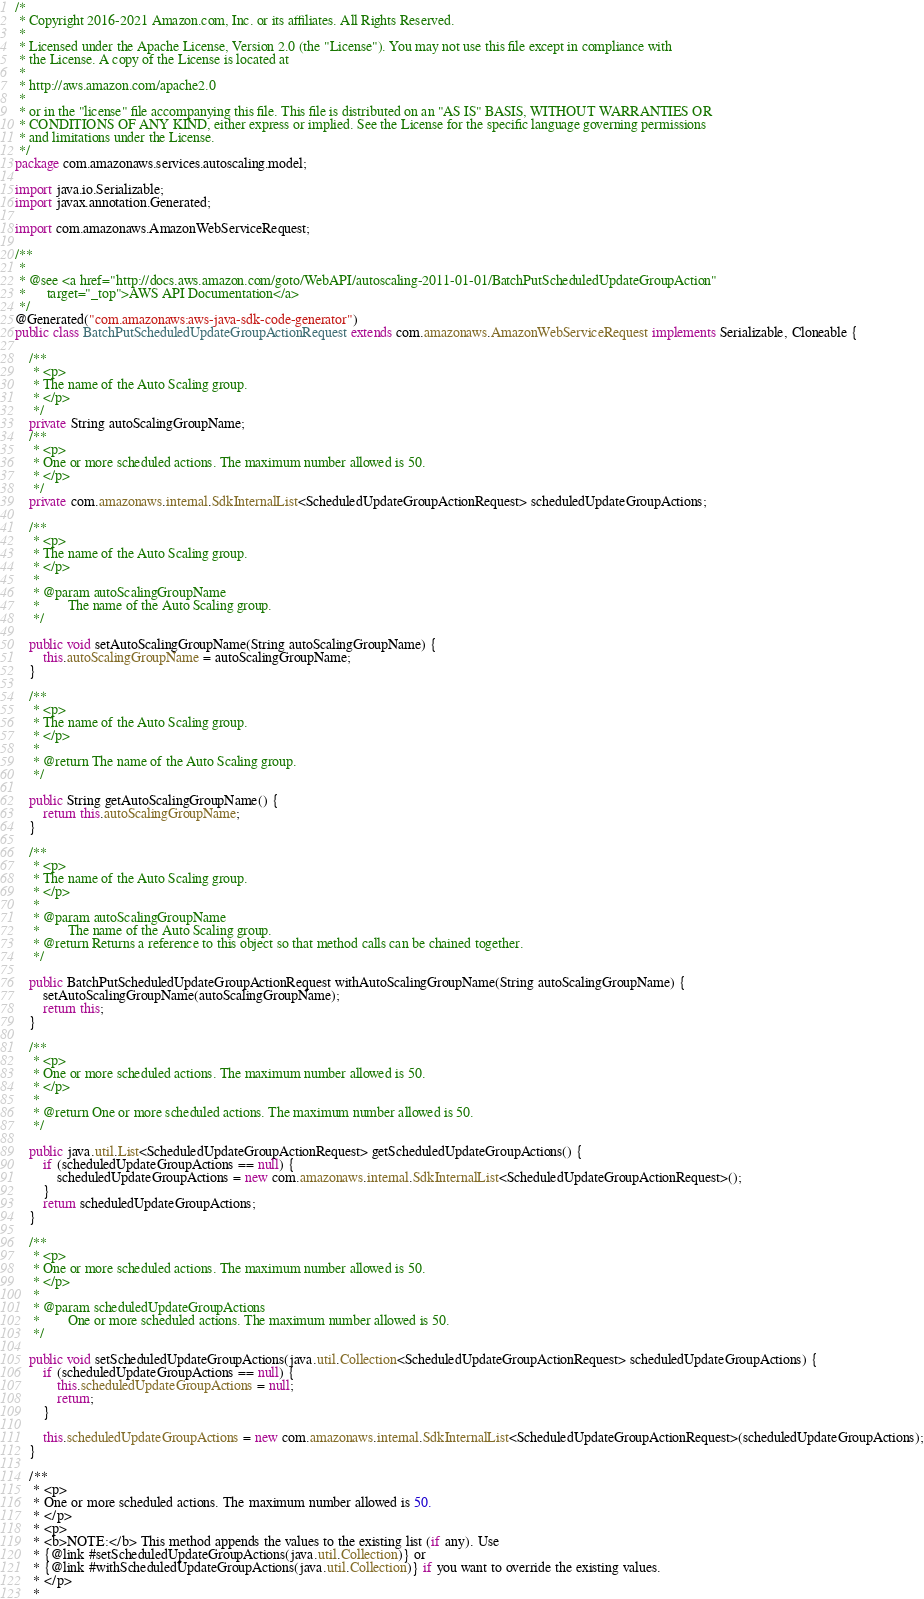Convert code to text. <code><loc_0><loc_0><loc_500><loc_500><_Java_>/*
 * Copyright 2016-2021 Amazon.com, Inc. or its affiliates. All Rights Reserved.
 * 
 * Licensed under the Apache License, Version 2.0 (the "License"). You may not use this file except in compliance with
 * the License. A copy of the License is located at
 * 
 * http://aws.amazon.com/apache2.0
 * 
 * or in the "license" file accompanying this file. This file is distributed on an "AS IS" BASIS, WITHOUT WARRANTIES OR
 * CONDITIONS OF ANY KIND, either express or implied. See the License for the specific language governing permissions
 * and limitations under the License.
 */
package com.amazonaws.services.autoscaling.model;

import java.io.Serializable;
import javax.annotation.Generated;

import com.amazonaws.AmazonWebServiceRequest;

/**
 * 
 * @see <a href="http://docs.aws.amazon.com/goto/WebAPI/autoscaling-2011-01-01/BatchPutScheduledUpdateGroupAction"
 *      target="_top">AWS API Documentation</a>
 */
@Generated("com.amazonaws:aws-java-sdk-code-generator")
public class BatchPutScheduledUpdateGroupActionRequest extends com.amazonaws.AmazonWebServiceRequest implements Serializable, Cloneable {

    /**
     * <p>
     * The name of the Auto Scaling group.
     * </p>
     */
    private String autoScalingGroupName;
    /**
     * <p>
     * One or more scheduled actions. The maximum number allowed is 50.
     * </p>
     */
    private com.amazonaws.internal.SdkInternalList<ScheduledUpdateGroupActionRequest> scheduledUpdateGroupActions;

    /**
     * <p>
     * The name of the Auto Scaling group.
     * </p>
     * 
     * @param autoScalingGroupName
     *        The name of the Auto Scaling group.
     */

    public void setAutoScalingGroupName(String autoScalingGroupName) {
        this.autoScalingGroupName = autoScalingGroupName;
    }

    /**
     * <p>
     * The name of the Auto Scaling group.
     * </p>
     * 
     * @return The name of the Auto Scaling group.
     */

    public String getAutoScalingGroupName() {
        return this.autoScalingGroupName;
    }

    /**
     * <p>
     * The name of the Auto Scaling group.
     * </p>
     * 
     * @param autoScalingGroupName
     *        The name of the Auto Scaling group.
     * @return Returns a reference to this object so that method calls can be chained together.
     */

    public BatchPutScheduledUpdateGroupActionRequest withAutoScalingGroupName(String autoScalingGroupName) {
        setAutoScalingGroupName(autoScalingGroupName);
        return this;
    }

    /**
     * <p>
     * One or more scheduled actions. The maximum number allowed is 50.
     * </p>
     * 
     * @return One or more scheduled actions. The maximum number allowed is 50.
     */

    public java.util.List<ScheduledUpdateGroupActionRequest> getScheduledUpdateGroupActions() {
        if (scheduledUpdateGroupActions == null) {
            scheduledUpdateGroupActions = new com.amazonaws.internal.SdkInternalList<ScheduledUpdateGroupActionRequest>();
        }
        return scheduledUpdateGroupActions;
    }

    /**
     * <p>
     * One or more scheduled actions. The maximum number allowed is 50.
     * </p>
     * 
     * @param scheduledUpdateGroupActions
     *        One or more scheduled actions. The maximum number allowed is 50.
     */

    public void setScheduledUpdateGroupActions(java.util.Collection<ScheduledUpdateGroupActionRequest> scheduledUpdateGroupActions) {
        if (scheduledUpdateGroupActions == null) {
            this.scheduledUpdateGroupActions = null;
            return;
        }

        this.scheduledUpdateGroupActions = new com.amazonaws.internal.SdkInternalList<ScheduledUpdateGroupActionRequest>(scheduledUpdateGroupActions);
    }

    /**
     * <p>
     * One or more scheduled actions. The maximum number allowed is 50.
     * </p>
     * <p>
     * <b>NOTE:</b> This method appends the values to the existing list (if any). Use
     * {@link #setScheduledUpdateGroupActions(java.util.Collection)} or
     * {@link #withScheduledUpdateGroupActions(java.util.Collection)} if you want to override the existing values.
     * </p>
     * </code> 